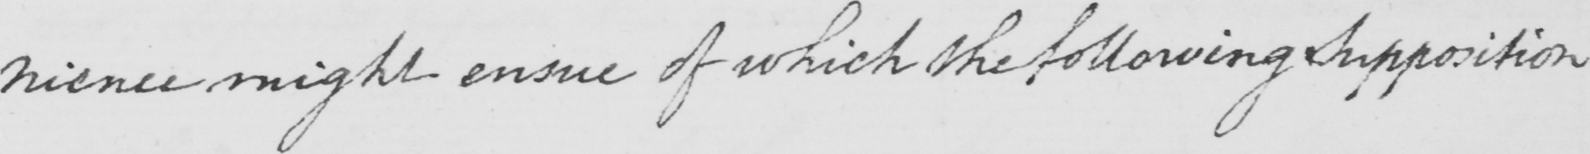What does this handwritten line say? might ensue of which the following Supposition 